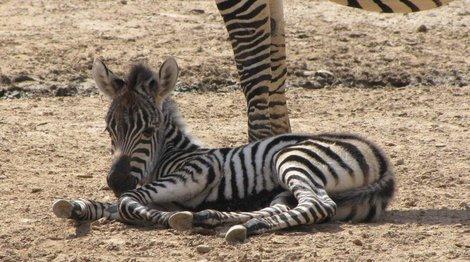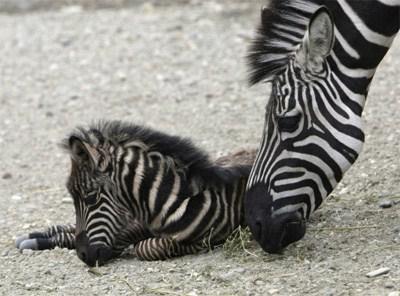The first image is the image on the left, the second image is the image on the right. Evaluate the accuracy of this statement regarding the images: "There are two zebras". Is it true? Answer yes or no. No. The first image is the image on the left, the second image is the image on the right. Considering the images on both sides, is "One image includes a zebra lying flat on its side with its head also flat on the brown ground." valid? Answer yes or no. No. 